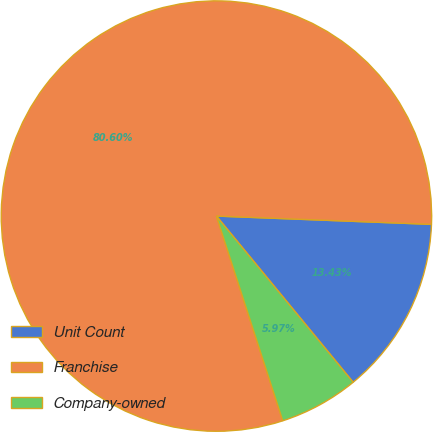<chart> <loc_0><loc_0><loc_500><loc_500><pie_chart><fcel>Unit Count<fcel>Franchise<fcel>Company-owned<nl><fcel>13.43%<fcel>80.6%<fcel>5.97%<nl></chart> 